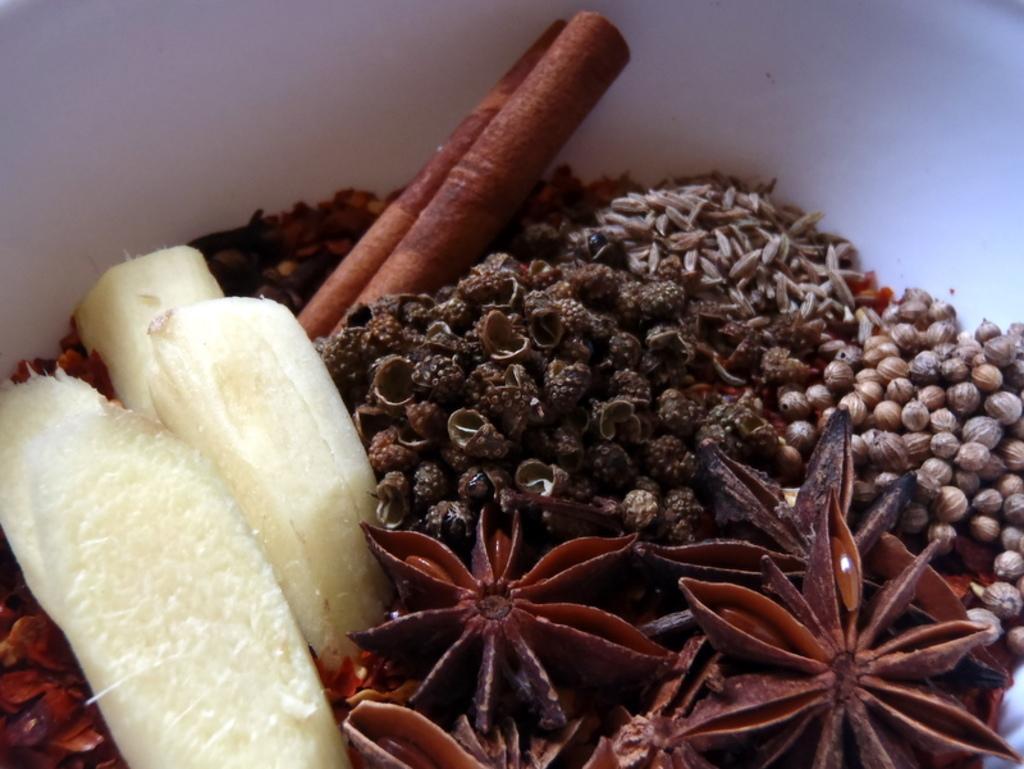Can you describe this image briefly? In this image there are cinnamon, star anise and some other spices. 